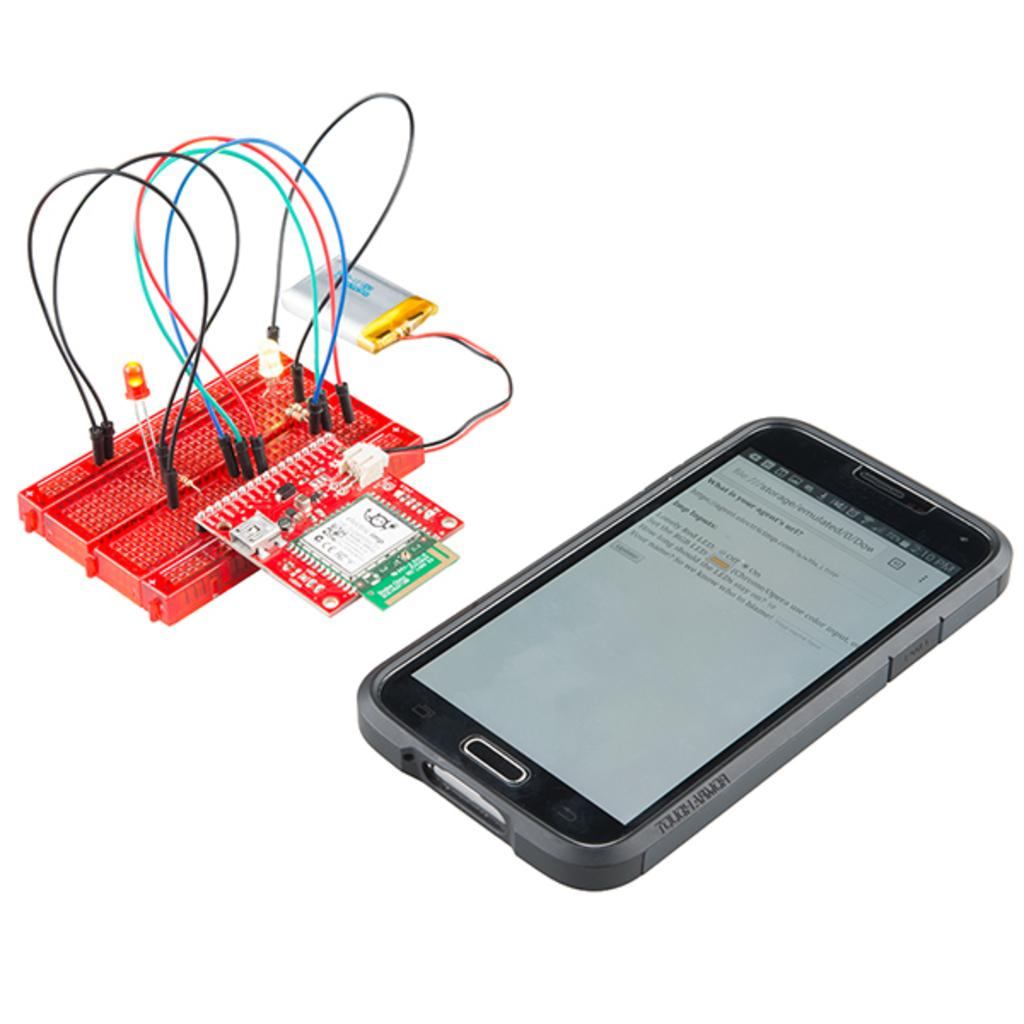<image>
Create a compact narrative representing the image presented. A phone whose screen shows it is 2:10 PM is next to a computer chip tester. 